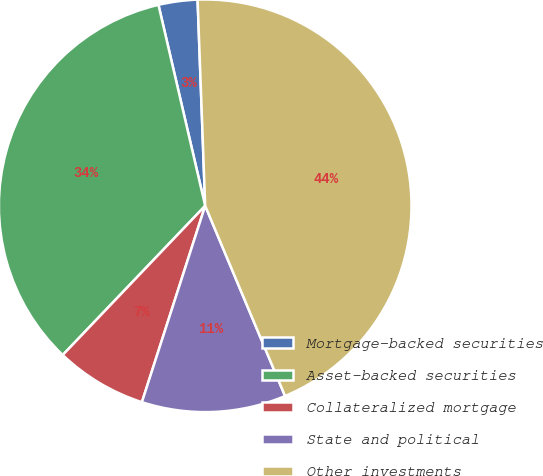Convert chart to OTSL. <chart><loc_0><loc_0><loc_500><loc_500><pie_chart><fcel>Mortgage-backed securities<fcel>Asset-backed securities<fcel>Collateralized mortgage<fcel>State and political<fcel>Other investments<nl><fcel>3.05%<fcel>34.23%<fcel>7.17%<fcel>11.29%<fcel>44.26%<nl></chart> 